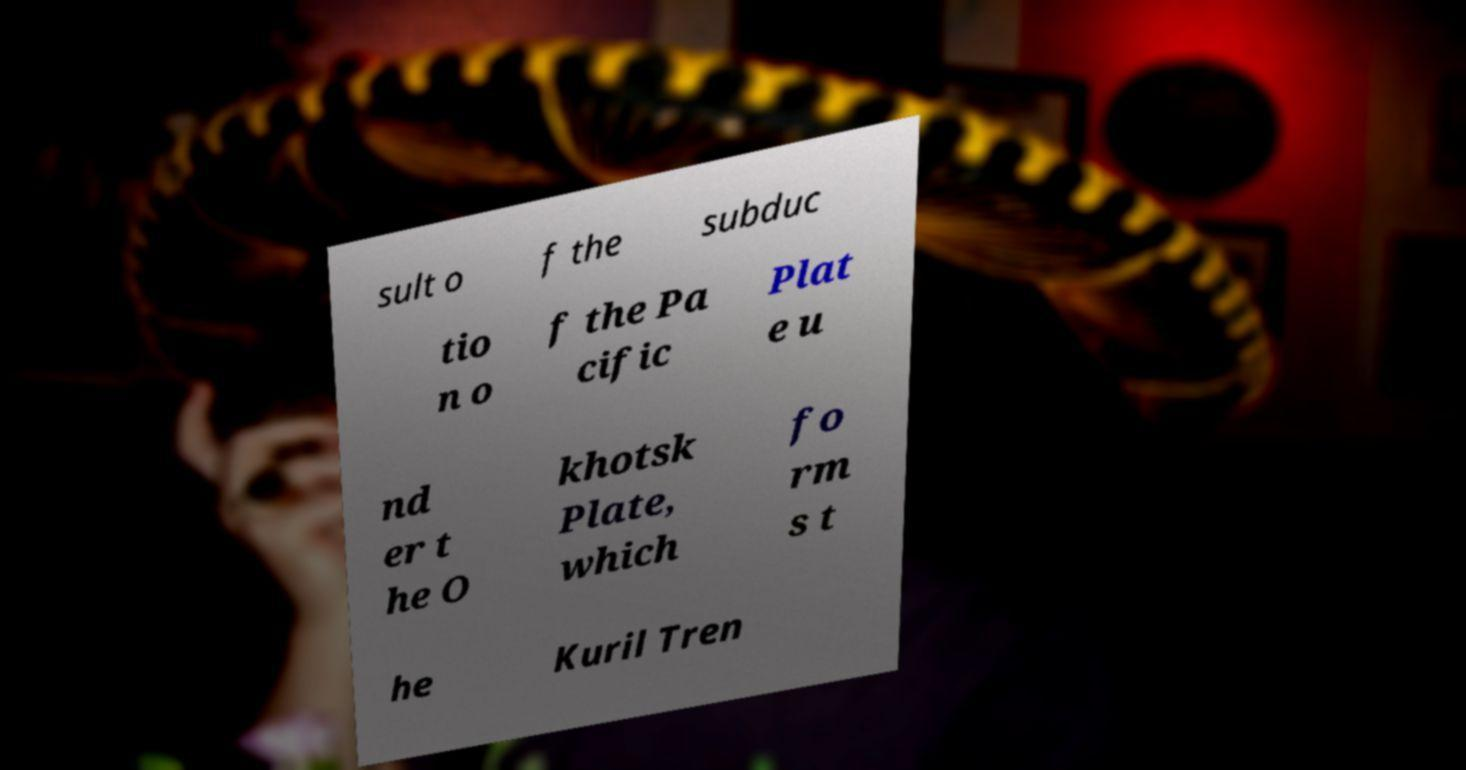For documentation purposes, I need the text within this image transcribed. Could you provide that? sult o f the subduc tio n o f the Pa cific Plat e u nd er t he O khotsk Plate, which fo rm s t he Kuril Tren 